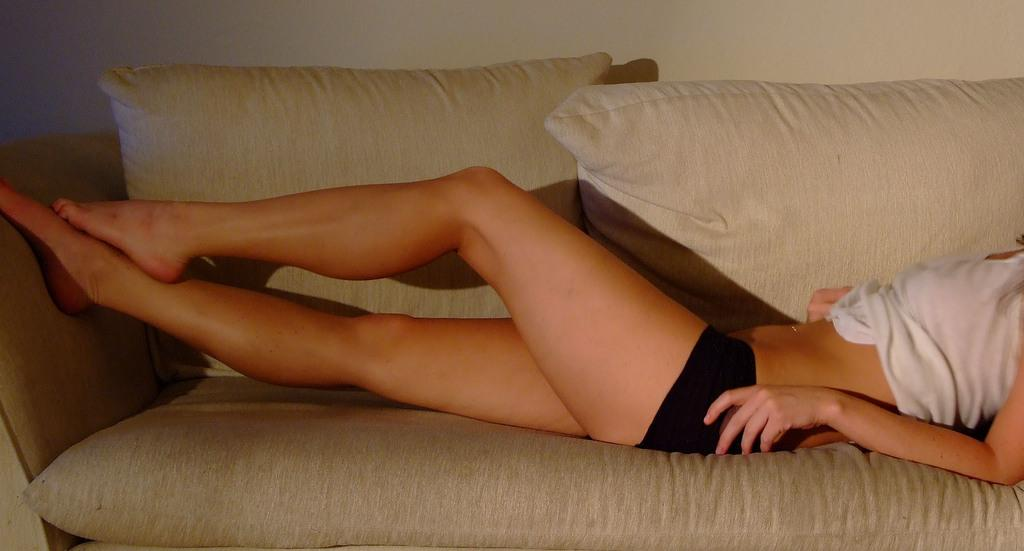Who is present in the image? There is a woman in the image. What is the woman doing in the image? The woman is lying on a sofa. What can be seen in the background of the image? There is a wall visible in the background of the image. What type of patch is the woman using to fix the sofa in the image? There is no patch visible in the image, nor is there any indication that the sofa needs fixing. 